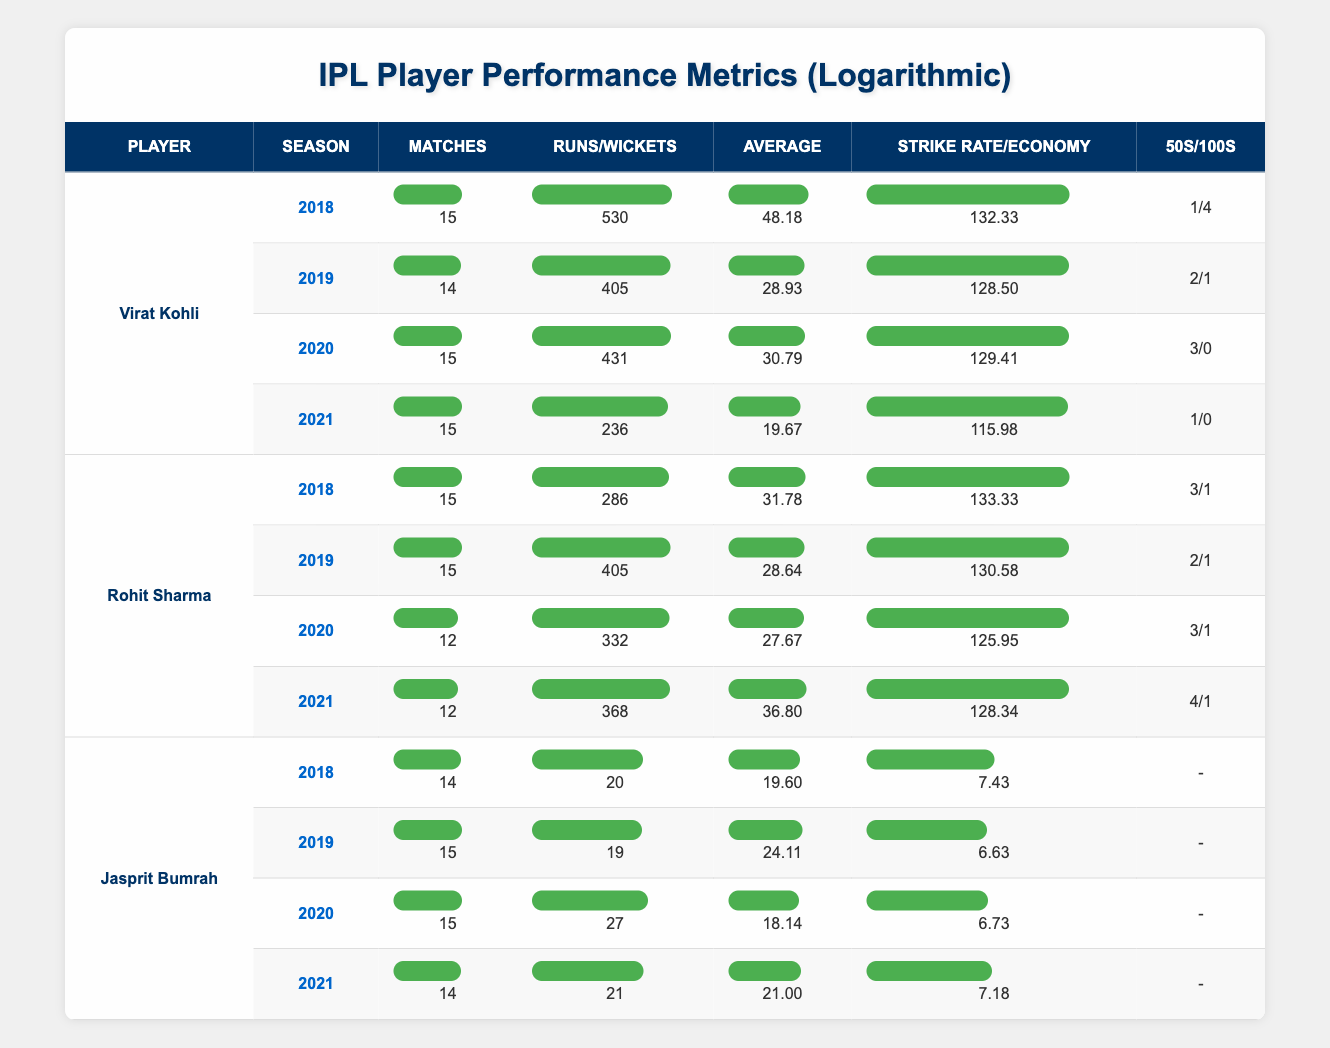What was Virat Kohli's highest number of runs in a single season within the table? In the table, I check each season for Virat Kohli. The runs for each season are: 2018 - 530, 2019 - 405, 2020 - 431, 2021 - 236. The highest among these is 530 in 2018.
Answer: 530 How many matches did Rohit Sharma play in 2020? For Rohit Sharma in the 2020 season, I look in the table where his matches are listed. It shows that he played 12 matches.
Answer: 12 True or False: Jasprit Bumrah had an average of less than 20 in 2020. I check the average for Jasprit Bumrah in the 2020 season, which is 18.14. Since 18.14 is less than 20, the statement is true.
Answer: True What was the difference in strike rates between Virat Kohli in 2018 and 2021? First, I find Virat Kohli's strike rates: in 2018, it was 132.33, and in 2021, it was 115.98. The difference is 132.33 - 115.98 = 16.35.
Answer: 16.35 Which player had the highest number of fifties in 2021? I look at the fifties column in the year 2021: Virat Kohli - 1, Rohit Sharma - 4, Jasprit Bumrah - N/A. The highest is 4 by Rohit Sharma.
Answer: Rohit Sharma What was the average number of runs scored by Rohit Sharma in the seasons 2018, 2019, and 2020? I need to calculate this by finding his runs: 2018 - 286, 2019 - 405, 2020 - 332. The total runs are 286 + 405 + 332 = 1023. Dividing this by the number of seasons (3) gives 1023 / 3 = 341.
Answer: 341 Did Jasprit Bumrah's economy rate improve from 2019 to 2020? Jasprit Bumrah's economy for 2019 is 6.63 and for 2020 it is 6.73. Since 6.73 is higher than 6.63, the economy rate did not improve, showing a decline.
Answer: No Which player scored the most hundreds across all seasons in the table? I check the hundreds columns for all players across the seasons. Virat Kohli has 4, Rohit Sharma has 3, and Jasprit Bumrah has 0. Thus, Virat Kohli scored the most hundreds.
Answer: Virat Kohli 